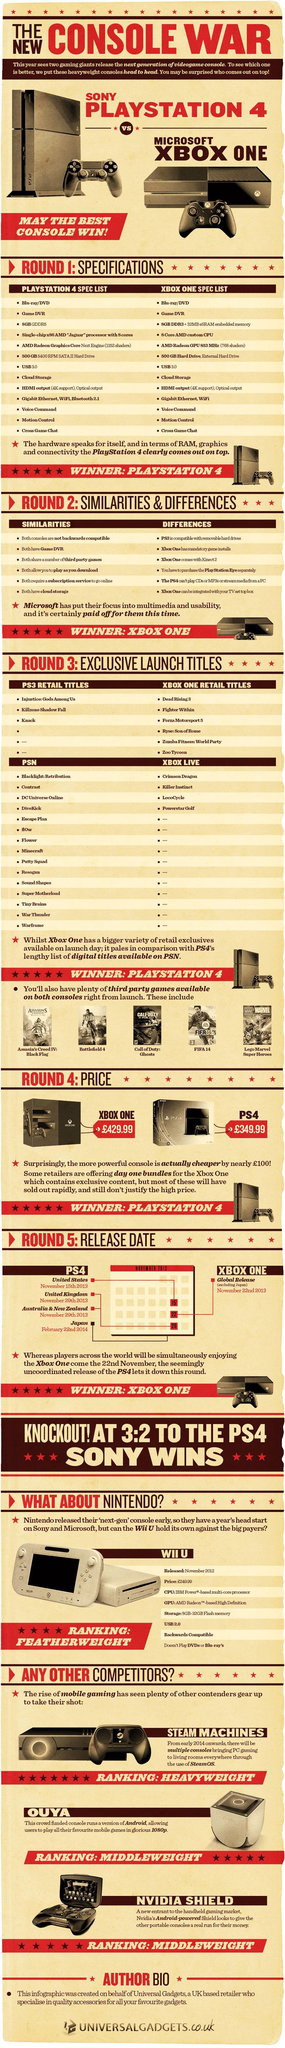What is the primary operating system used for the Steam Machine gaming platform?
Answer the question with a short phrase. SteamOS When was PS4 launched in Japan? February 22nd 2014 Which is a home video game console developed by Microsoft? XBOX ONE Where was the first PS4 launched? United States Which is a home video game console developed by Nintendo? WII U 